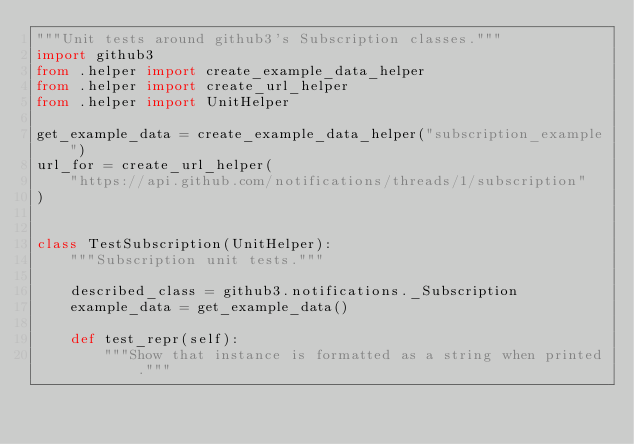Convert code to text. <code><loc_0><loc_0><loc_500><loc_500><_Python_>"""Unit tests around github3's Subscription classes."""
import github3
from .helper import create_example_data_helper
from .helper import create_url_helper
from .helper import UnitHelper

get_example_data = create_example_data_helper("subscription_example")
url_for = create_url_helper(
    "https://api.github.com/notifications/threads/1/subscription"
)


class TestSubscription(UnitHelper):
    """Subscription unit tests."""

    described_class = github3.notifications._Subscription
    example_data = get_example_data()

    def test_repr(self):
        """Show that instance is formatted as a string when printed."""</code> 